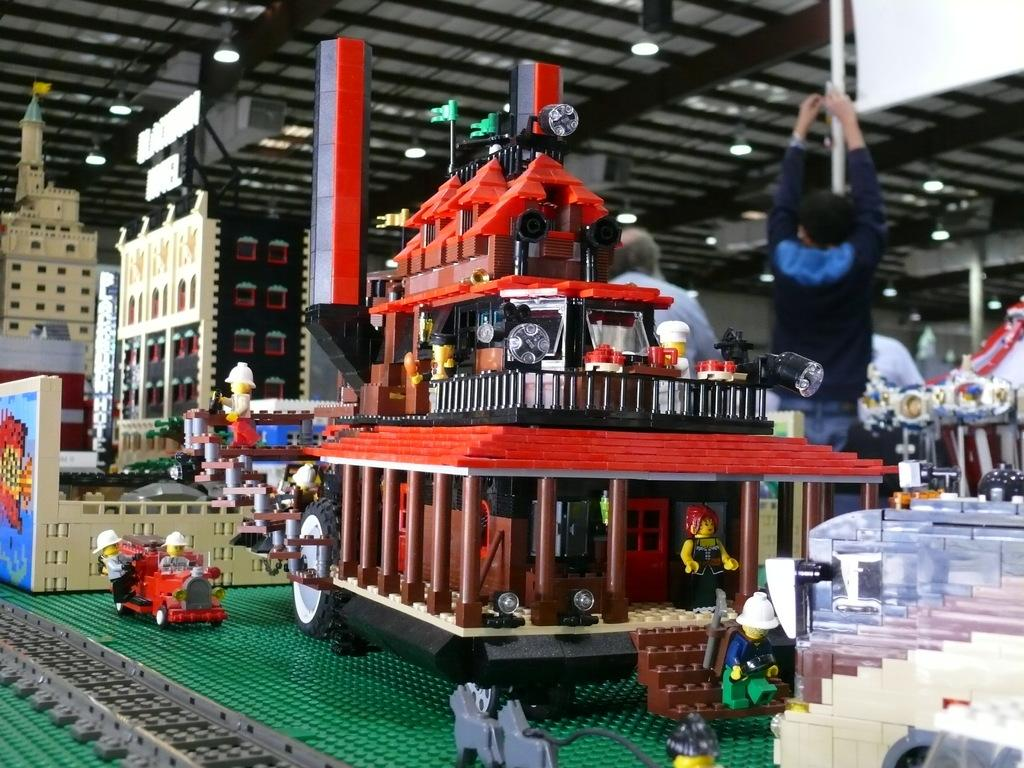What type of toys are present in the image? There are toys with building blocks in the image. How many people can be seen in the image? There are two persons in the image. What is visible above the scene in the image? There is a ceiling with lights visible in the image. How many rings are being worn by the persons in the image? There is no information about rings in the image; the focus is on the toys and the presence of two people. 